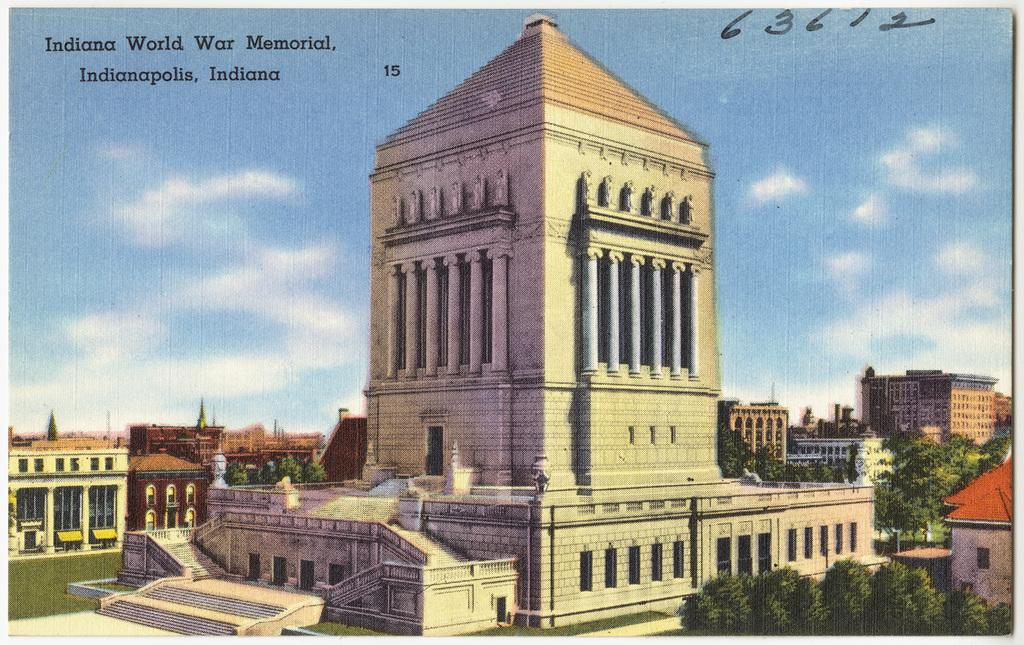<image>
Offer a succinct explanation of the picture presented. a mural of the indiana world war memorial 